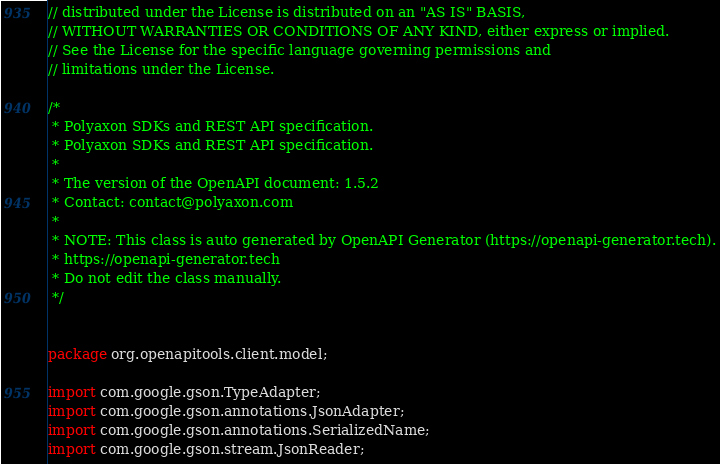<code> <loc_0><loc_0><loc_500><loc_500><_Java_>// distributed under the License is distributed on an "AS IS" BASIS,
// WITHOUT WARRANTIES OR CONDITIONS OF ANY KIND, either express or implied.
// See the License for the specific language governing permissions and
// limitations under the License.

/*
 * Polyaxon SDKs and REST API specification.
 * Polyaxon SDKs and REST API specification.
 *
 * The version of the OpenAPI document: 1.5.2
 * Contact: contact@polyaxon.com
 *
 * NOTE: This class is auto generated by OpenAPI Generator (https://openapi-generator.tech).
 * https://openapi-generator.tech
 * Do not edit the class manually.
 */


package org.openapitools.client.model;

import com.google.gson.TypeAdapter;
import com.google.gson.annotations.JsonAdapter;
import com.google.gson.annotations.SerializedName;
import com.google.gson.stream.JsonReader;</code> 